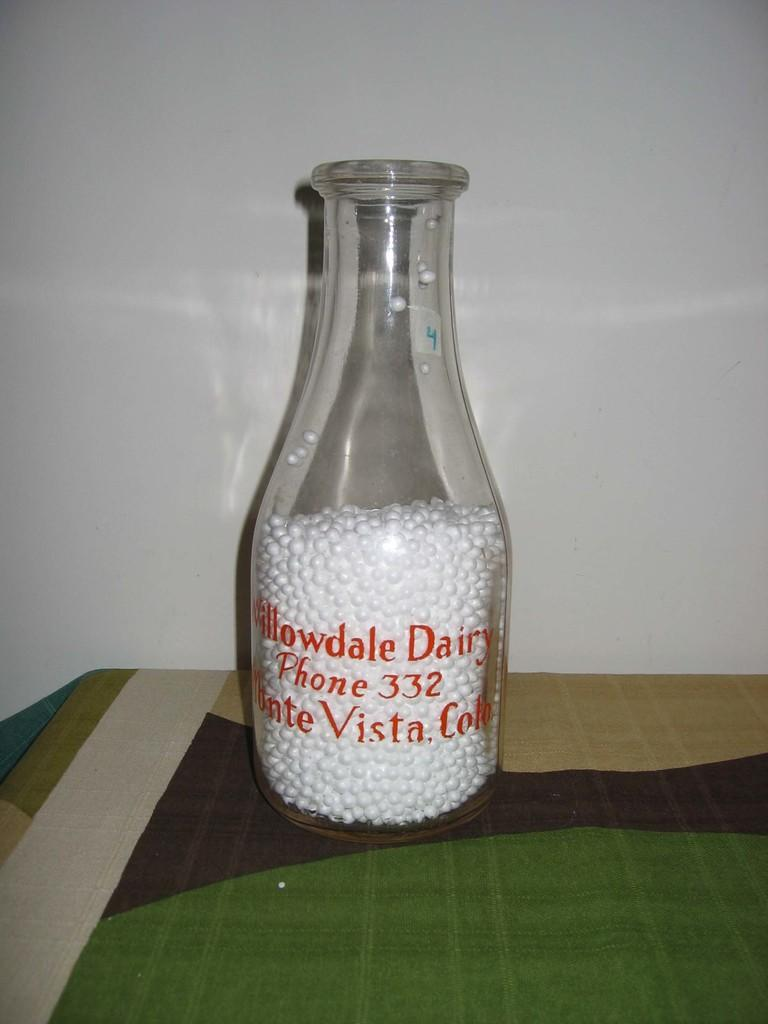Provide a one-sentence caption for the provided image. An old glass jar with white beads in it has Willowdale  Dairy written in red. 